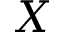Convert formula to latex. <formula><loc_0><loc_0><loc_500><loc_500>X</formula> 